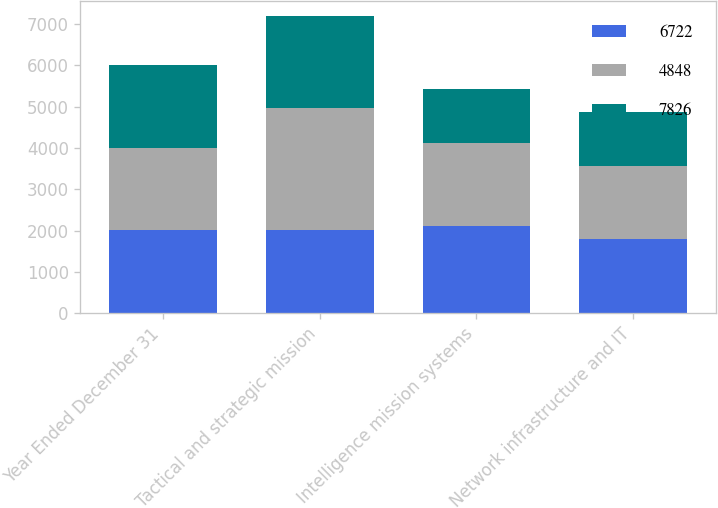<chart> <loc_0><loc_0><loc_500><loc_500><stacked_bar_chart><ecel><fcel>Year Ended December 31<fcel>Tactical and strategic mission<fcel>Intelligence mission systems<fcel>Network infrastructure and IT<nl><fcel>6722<fcel>2005<fcel>2004<fcel>2110<fcel>1804<nl><fcel>4848<fcel>2004<fcel>2966<fcel>2006<fcel>1750<nl><fcel>7826<fcel>2003<fcel>2221<fcel>1314<fcel>1313<nl></chart> 